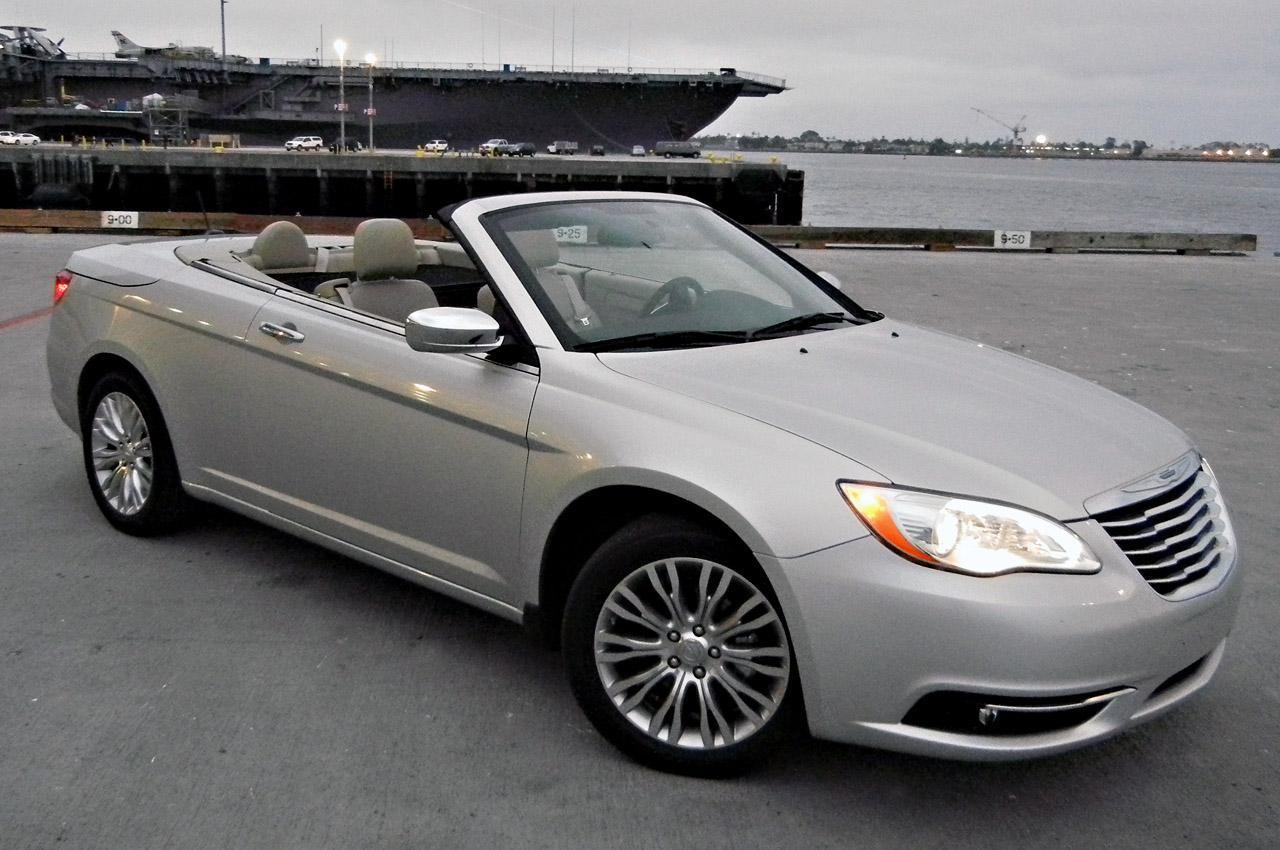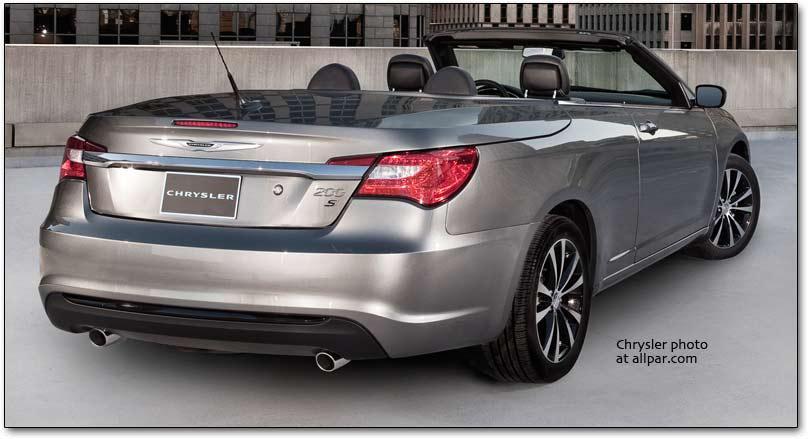The first image is the image on the left, the second image is the image on the right. For the images displayed, is the sentence "The car in the image on the right has a top." factually correct? Answer yes or no. No. 